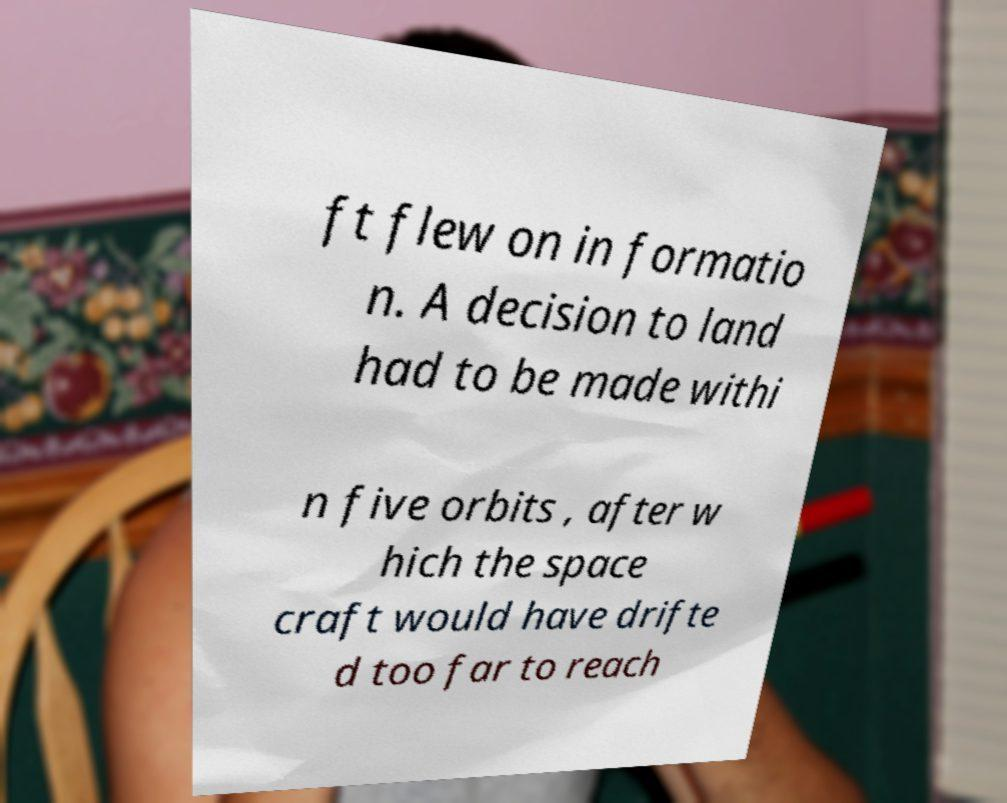I need the written content from this picture converted into text. Can you do that? ft flew on in formatio n. A decision to land had to be made withi n five orbits , after w hich the space craft would have drifte d too far to reach 